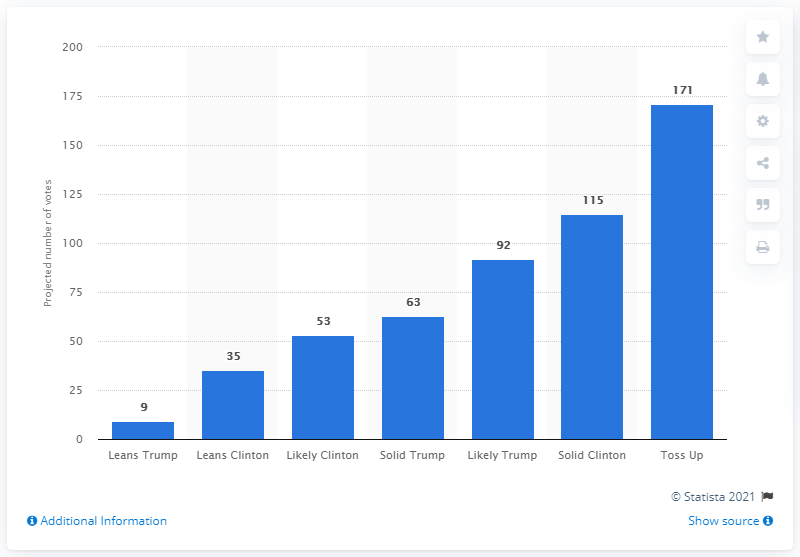Mention a couple of crucial points in this snapshot. As of November 8, 2016, there were 171 electoral votes that were considered a toss-up between the candidates. 